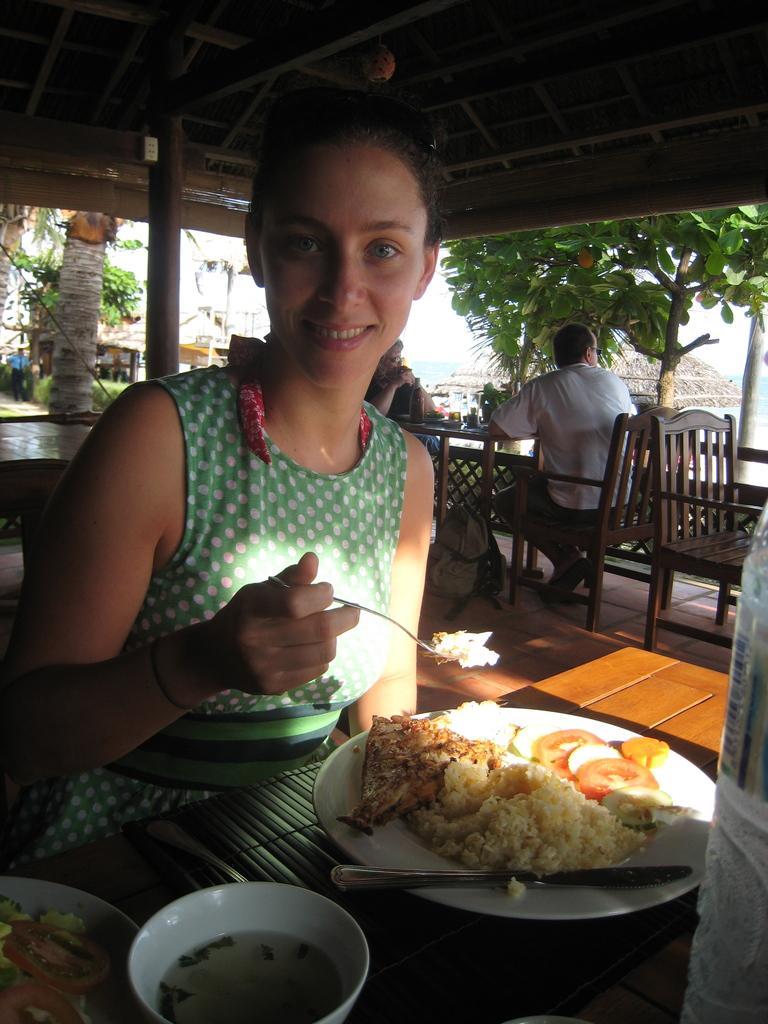How would you summarize this image in a sentence or two? In the picture we can find a woman sitting on the chair near the table. She is holding a spoon of food and a plate we can find some food, rice near to the plate we can find one bowl and a knife. In the background we can find some chairs and a person sitting on it. And trees, sky, and houses. 